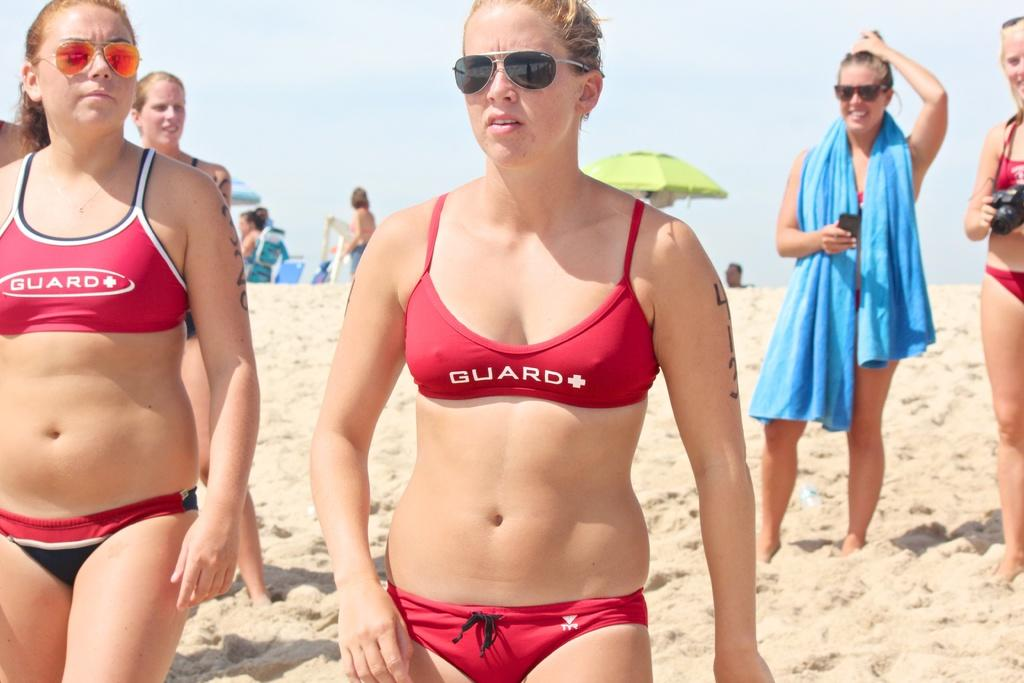<image>
Write a terse but informative summary of the picture. The two girls shown are wearing bikini tops saying Guard on them. 